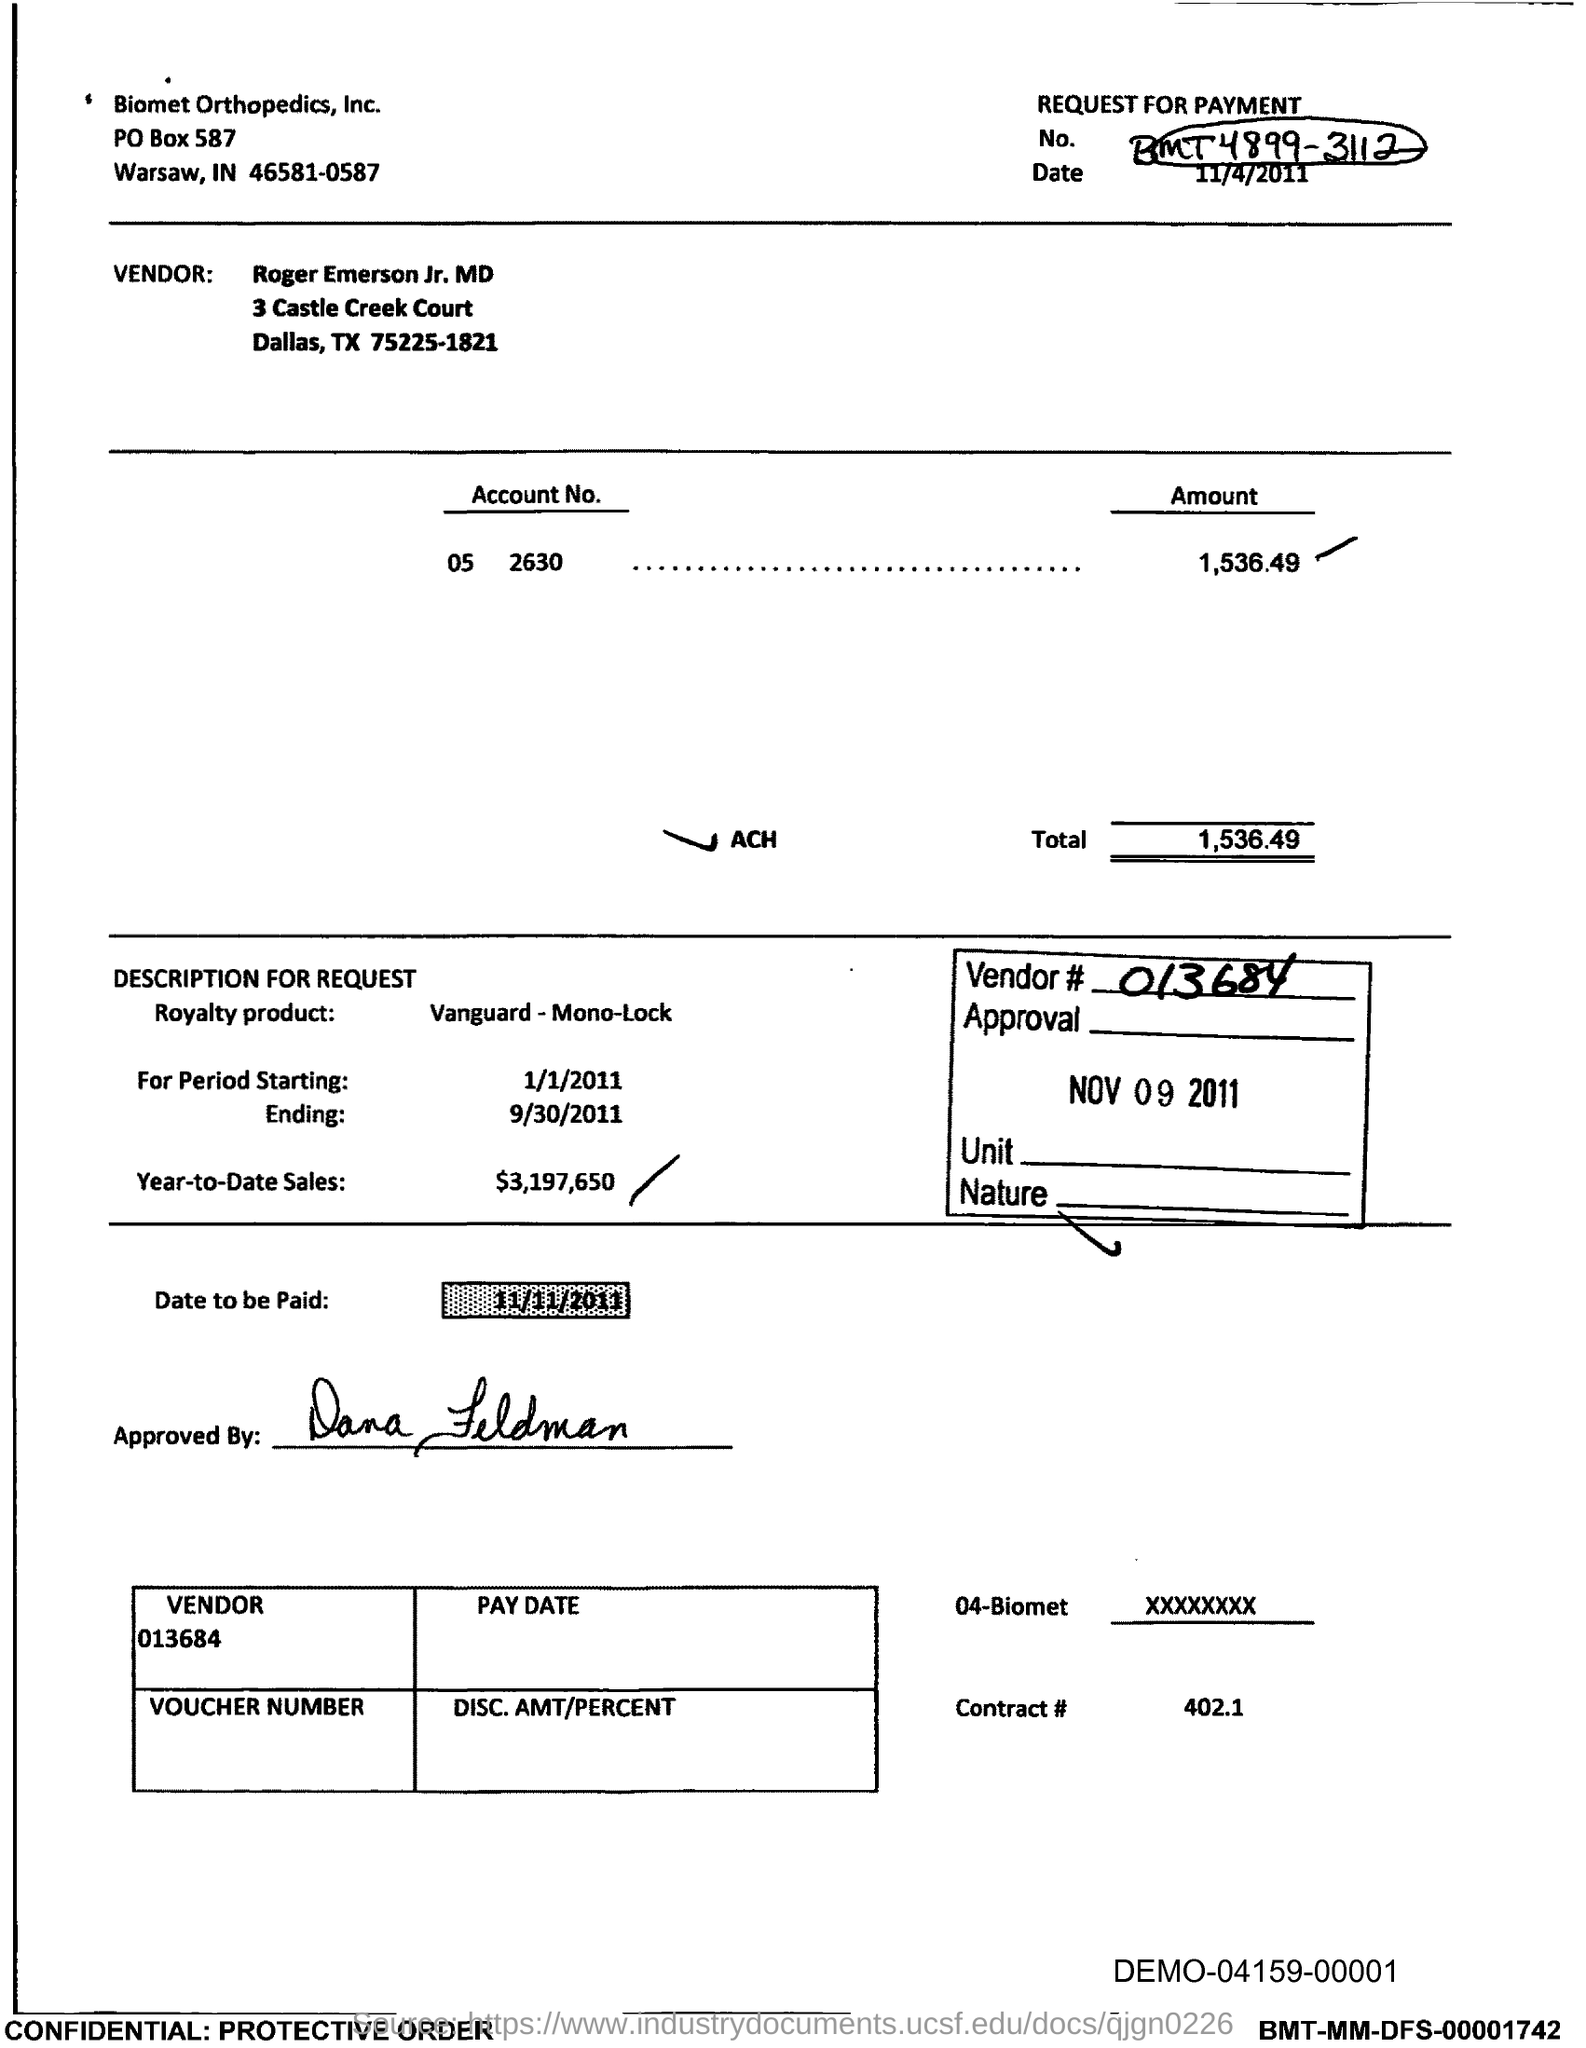Specify some key components in this picture. The total is 1,536.49. Could you please provide the vendor number for 013684... As of today's date, the year-to-date sales total $3,197,650. The PO box number for Biomet Orthopedics, Inc. is 587. I request to be informed of the date on which the payment is due, specifically November 11th, 2011. 